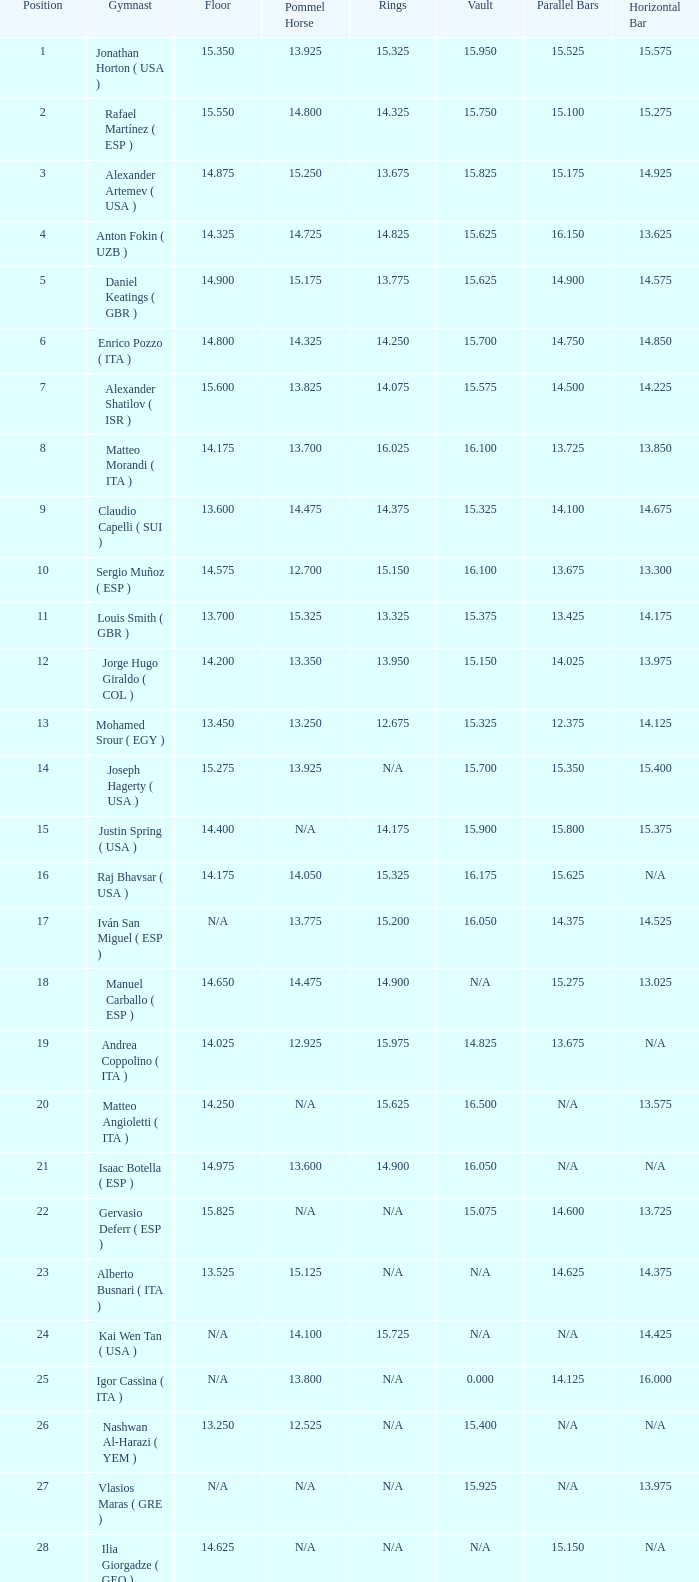If the horizontal bar is n/a and the floor is 14.175, what is the number for the parallel bars? 15.625. 